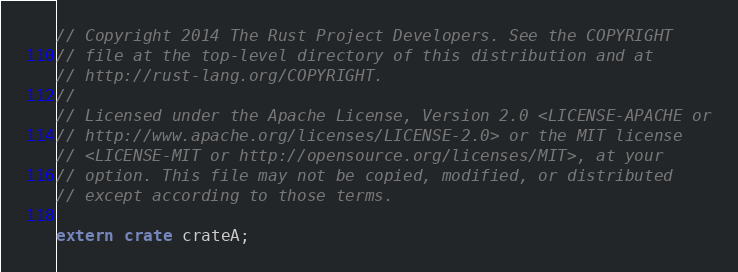<code> <loc_0><loc_0><loc_500><loc_500><_Rust_>// Copyright 2014 The Rust Project Developers. See the COPYRIGHT
// file at the top-level directory of this distribution and at
// http://rust-lang.org/COPYRIGHT.
//
// Licensed under the Apache License, Version 2.0 <LICENSE-APACHE or
// http://www.apache.org/licenses/LICENSE-2.0> or the MIT license
// <LICENSE-MIT or http://opensource.org/licenses/MIT>, at your
// option. This file may not be copied, modified, or distributed
// except according to those terms.

extern crate crateA;
</code> 